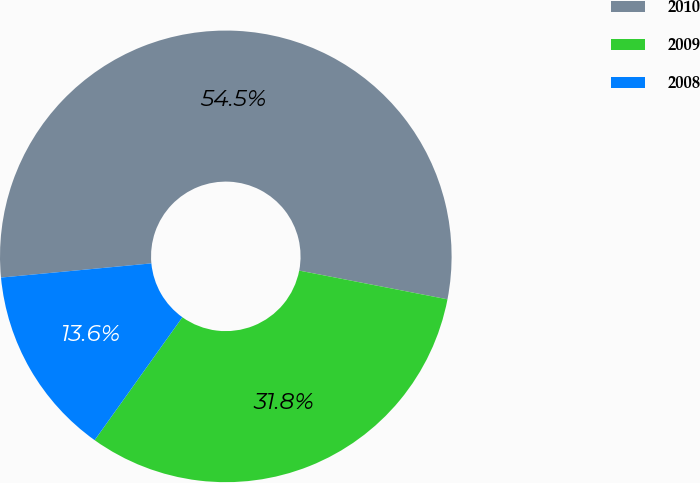Convert chart. <chart><loc_0><loc_0><loc_500><loc_500><pie_chart><fcel>2010<fcel>2009<fcel>2008<nl><fcel>54.55%<fcel>31.82%<fcel>13.64%<nl></chart> 